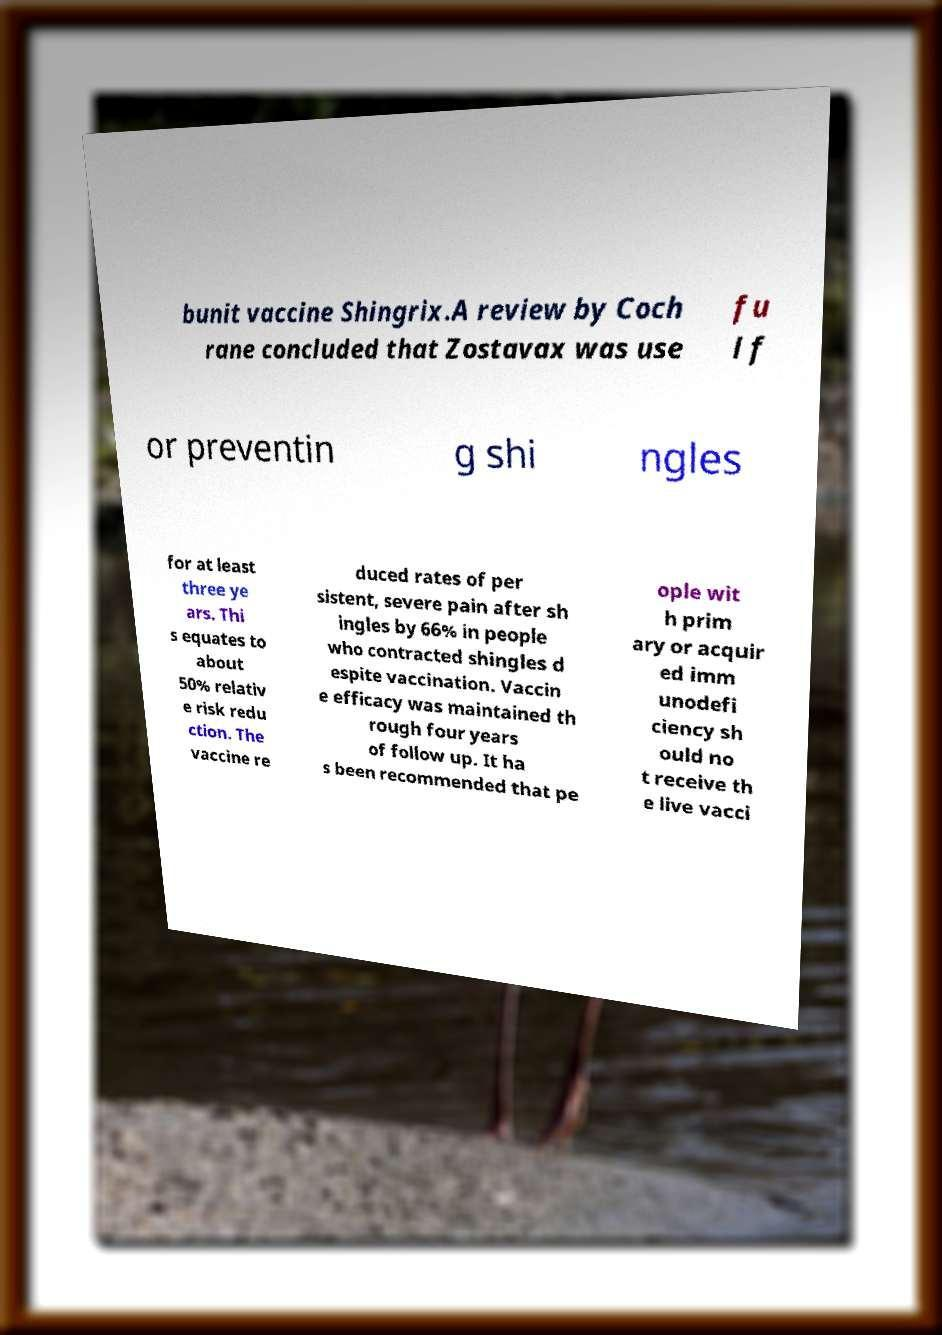Please identify and transcribe the text found in this image. bunit vaccine Shingrix.A review by Coch rane concluded that Zostavax was use fu l f or preventin g shi ngles for at least three ye ars. Thi s equates to about 50% relativ e risk redu ction. The vaccine re duced rates of per sistent, severe pain after sh ingles by 66% in people who contracted shingles d espite vaccination. Vaccin e efficacy was maintained th rough four years of follow up. It ha s been recommended that pe ople wit h prim ary or acquir ed imm unodefi ciency sh ould no t receive th e live vacci 